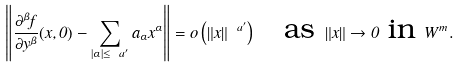<formula> <loc_0><loc_0><loc_500><loc_500>\left \| \frac { \partial ^ { \beta } f } { \partial y ^ { \beta } } ( x , 0 ) - \sum _ { | \alpha | \leq \ a ^ { \prime } } a _ { \alpha } x ^ { \alpha } \right \| = o \left ( \| x \| ^ { \ a ^ { \prime } } \right ) \quad \text {as } \| x \| \to 0 \text { in } W ^ { m } .</formula> 